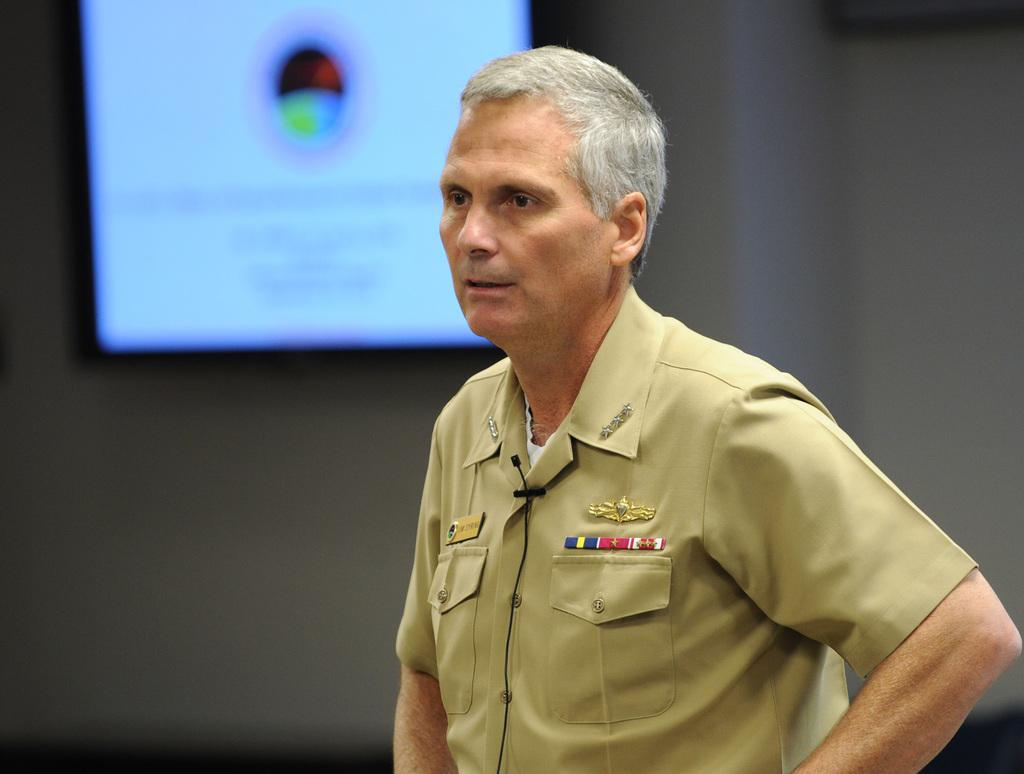What is the main subject of the image? There is a man in the image. Can you describe the background of the image? There is a screen on the wall in the background of the image. What type of rod can be seen in the image? There is no rod present in the image. What sound can be heard coming from the screen in the image? The image is silent, so no sound can be heard. 